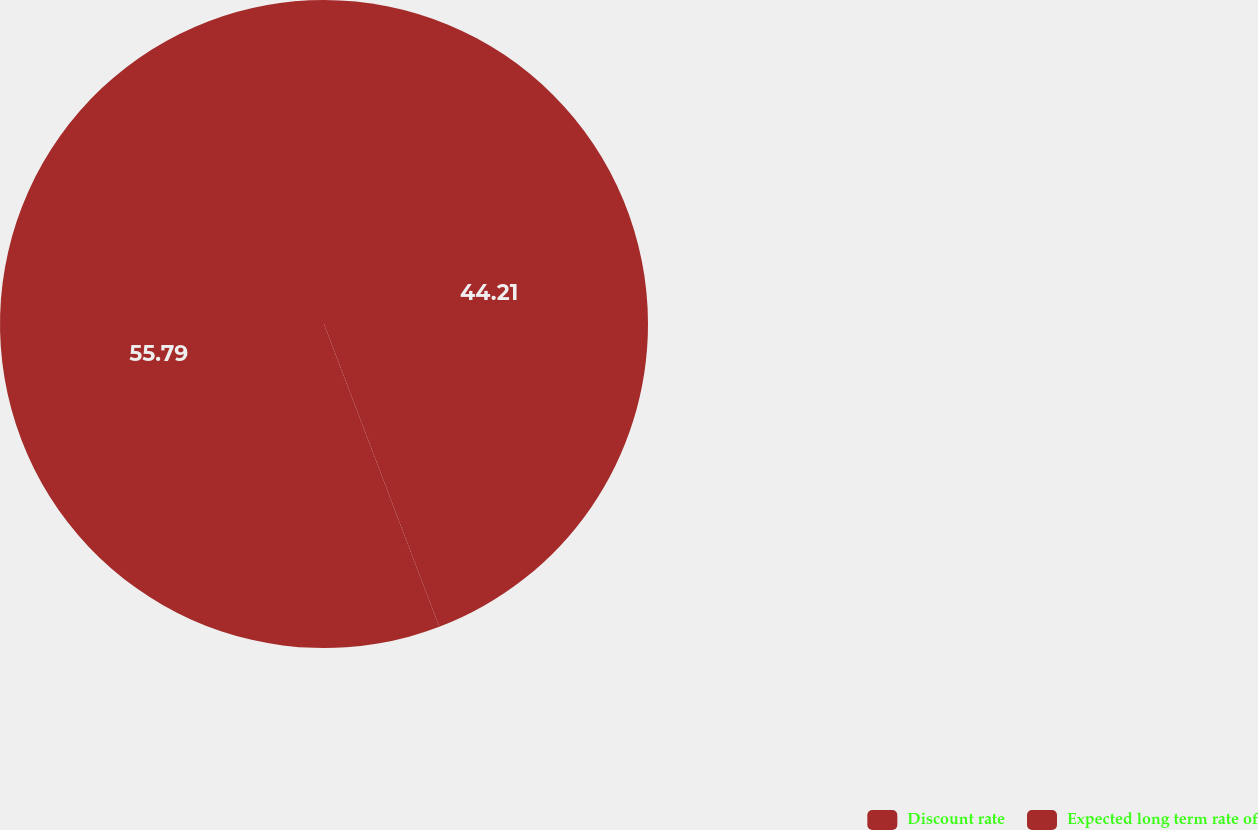<chart> <loc_0><loc_0><loc_500><loc_500><pie_chart><fcel>Discount rate<fcel>Expected long term rate of<nl><fcel>44.21%<fcel>55.79%<nl></chart> 